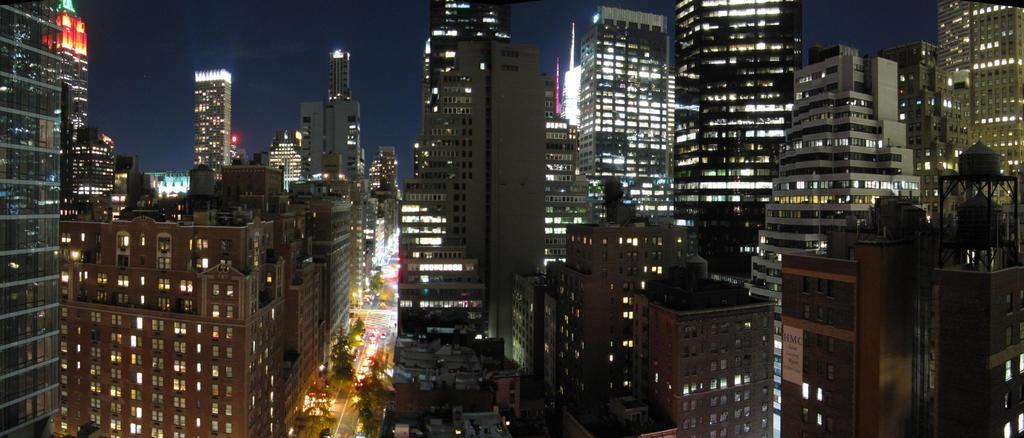What type of structures can be seen in the image? There are many buildings in the image. What else can be seen in the image besides buildings? There are lights visible in the image, as well as trees. What is happening on the road in the image? Vehicles are moving on the road in the image. How many icicles are hanging from the buildings in the image? There are no icicles present in the image; it is not snowing or cold enough for icicles to form. 